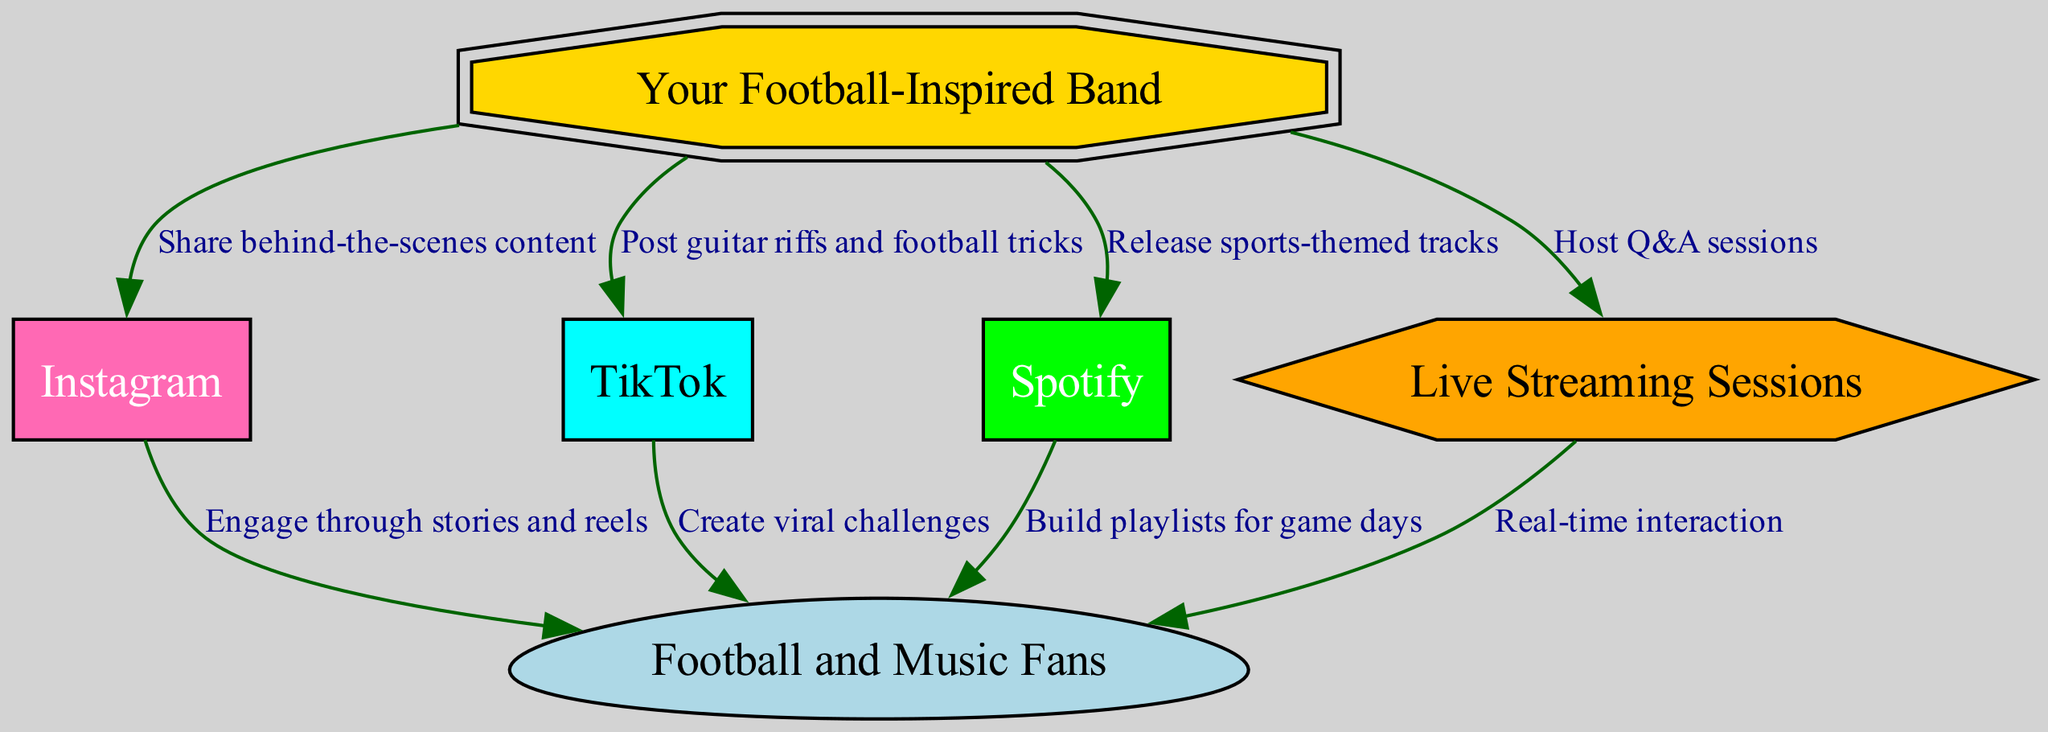What is the total number of nodes in the diagram? The diagram includes six nodes: Your Football-Inspired Band, Instagram, TikTok, Spotify, Football and Music Fans, and Live Streaming Sessions. Therefore, the total number of nodes is six.
Answer: 6 What type of content does the band share on Instagram? The diagram indicates that the band shares behind-the-scenes content on Instagram, as specified in the edge labeled "Share behind-the-scenes content."
Answer: Share behind-the-scenes content What action does TikTok allow the band to perform? According to the edge connecting the band and TikTok, the band can post guitar riffs and football tricks. This is stated in the edge labeled "Post guitar riffs and football tricks."
Answer: Post guitar riffs and football tricks How do fans engage with the band through Instagram? The diagram shows that fans engage through stories and reels, which is noted in the edge connecting Instagram and fans labeled "Engage through stories and reels."
Answer: Engage through stories and reels What is the purpose of the live streaming sessions? The band hosts Q&A sessions during live streaming sessions, as specified by the edge labeled "Host Q&A sessions." This indicates the main activity performed during live streams.
Answer: Host Q&A sessions Which platform is used to build playlists for game days? The diagram indicates that Spotify is used for building playlists for game days, as represented in the edge labeled "Build playlists for game days."
Answer: Spotify What type of interaction occurs during live streams? The diagram states that there is real-time interaction between fans and the band during live streaming sessions, as highlighted in the edge labeled "Real-time interaction."
Answer: Real-time interaction Which platform allows the band to create viral challenges? The diagram shows that TikTok allows the band to create viral challenges, evidenced by the edge labeled "Create viral challenges."
Answer: TikTok How many edges connect the band to other nodes? The diagram includes four edges that connect the band to other nodes: to Instagram, TikTok, Spotify, and Live Streaming Sessions. This means there are four edges in total.
Answer: 4 